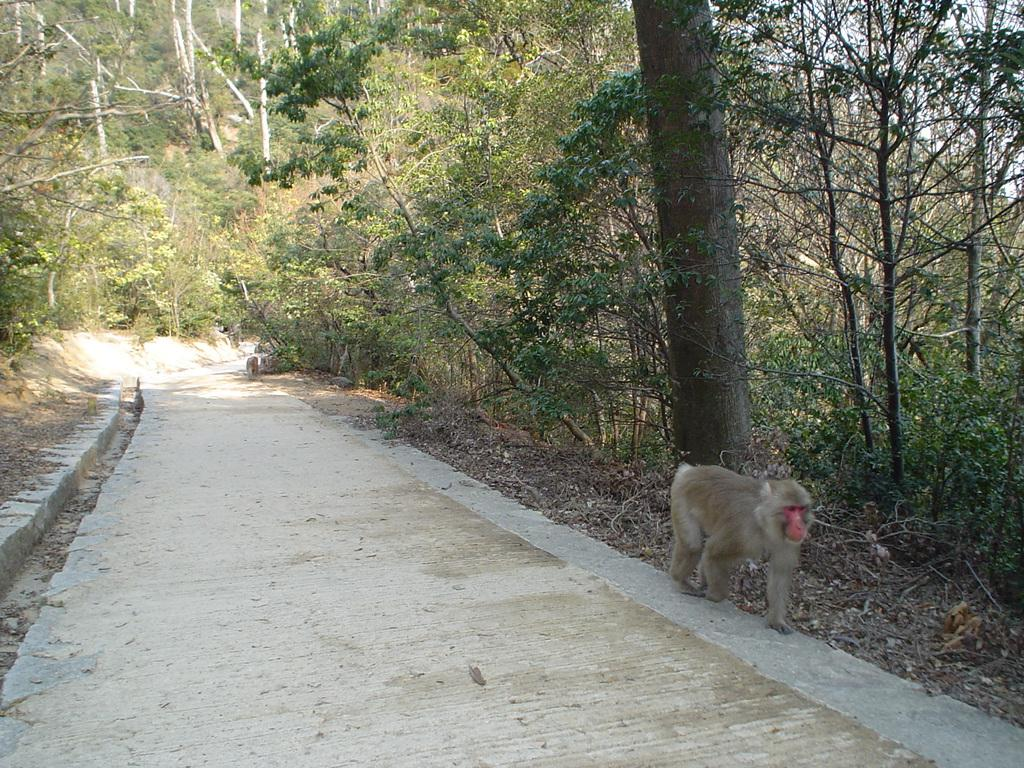What animal is present in the image? There is a monkey in the image. Where is the monkey located? The monkey is on the road. What can be seen in the background of the image? There are trees in the background of the image. What type of apparatus is being used by the monkey in the image? There is no apparatus present in the image; the monkey is simply on the road. What kind of rail can be seen in the image? There is no rail present in the image. 